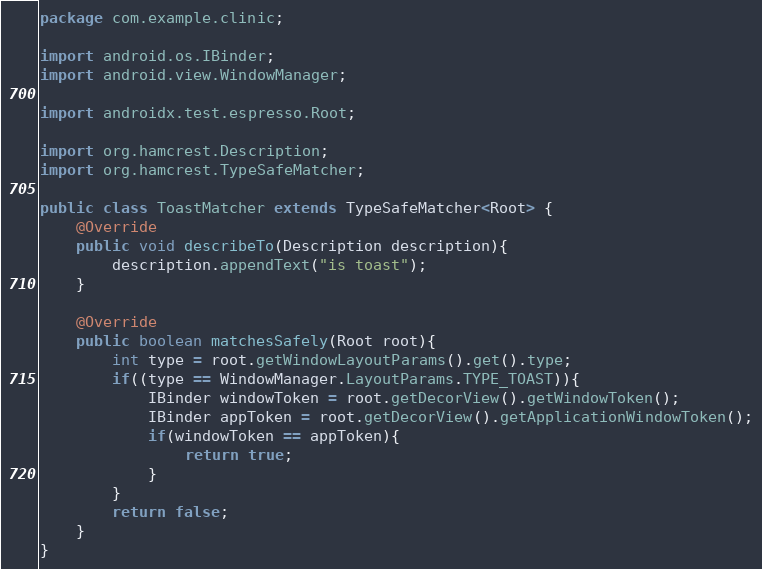Convert code to text. <code><loc_0><loc_0><loc_500><loc_500><_Java_>package com.example.clinic;

import android.os.IBinder;
import android.view.WindowManager;

import androidx.test.espresso.Root;

import org.hamcrest.Description;
import org.hamcrest.TypeSafeMatcher;

public class ToastMatcher extends TypeSafeMatcher<Root> {
    @Override
    public void describeTo(Description description){
        description.appendText("is toast");
    }

    @Override
    public boolean matchesSafely(Root root){
        int type = root.getWindowLayoutParams().get().type;
        if((type == WindowManager.LayoutParams.TYPE_TOAST)){
            IBinder windowToken = root.getDecorView().getWindowToken();
            IBinder appToken = root.getDecorView().getApplicationWindowToken();
            if(windowToken == appToken){
                return true;
            }
        }
        return false;
    }
}
</code> 